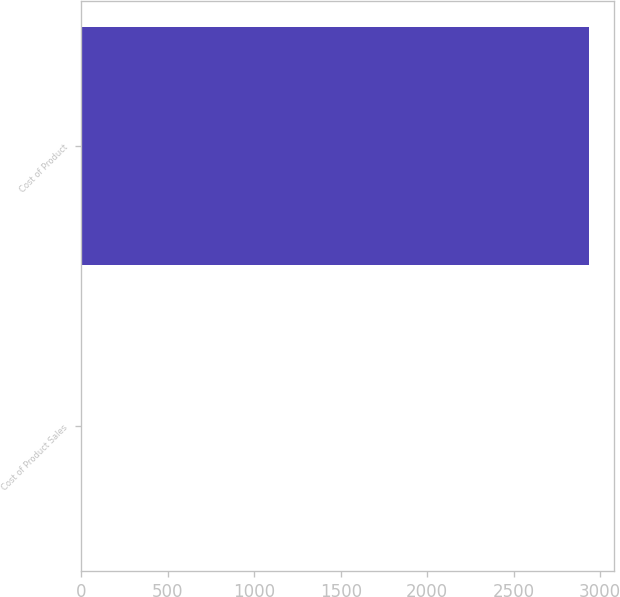Convert chart to OTSL. <chart><loc_0><loc_0><loc_500><loc_500><bar_chart><fcel>Cost of Product Sales<fcel>Cost of Product<nl><fcel>5<fcel>2934<nl></chart> 